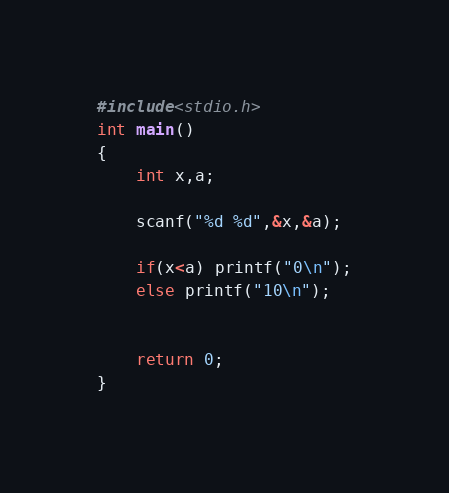<code> <loc_0><loc_0><loc_500><loc_500><_C_>#include<stdio.h>
int main()
{
    int x,a;

    scanf("%d %d",&x,&a);

    if(x<a) printf("0\n");
    else printf("10\n");


    return 0;
}
</code> 